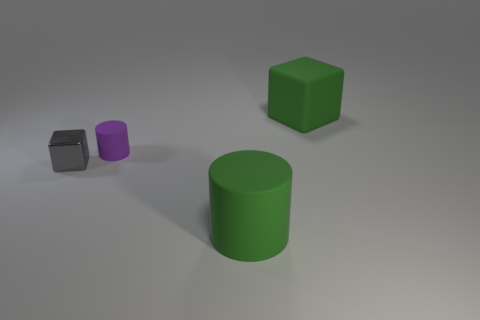Add 2 small purple objects. How many objects exist? 6 Add 3 small blue shiny balls. How many small blue shiny balls exist? 3 Subtract 0 yellow spheres. How many objects are left? 4 Subtract all tiny gray metallic blocks. Subtract all small gray cubes. How many objects are left? 2 Add 2 large matte cylinders. How many large matte cylinders are left? 3 